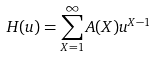Convert formula to latex. <formula><loc_0><loc_0><loc_500><loc_500>H ( u ) = \sum _ { X = 1 } ^ { \infty } A ( X ) u ^ { X - 1 }</formula> 